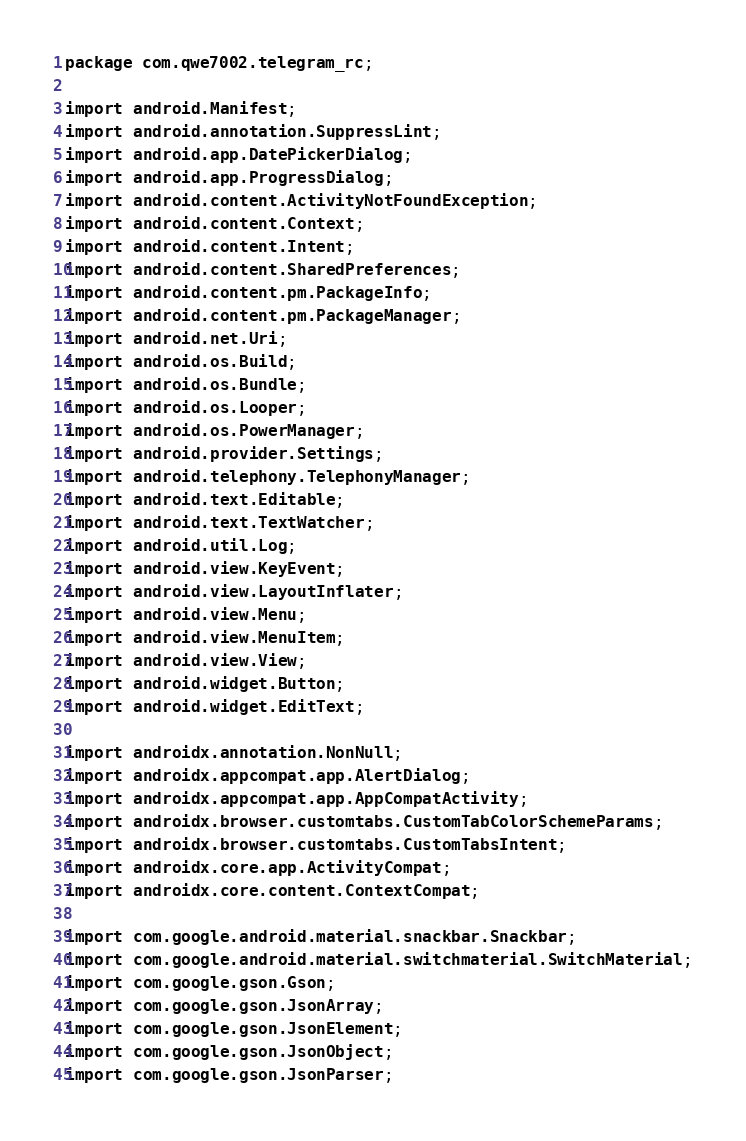Convert code to text. <code><loc_0><loc_0><loc_500><loc_500><_Java_>package com.qwe7002.telegram_rc;

import android.Manifest;
import android.annotation.SuppressLint;
import android.app.DatePickerDialog;
import android.app.ProgressDialog;
import android.content.ActivityNotFoundException;
import android.content.Context;
import android.content.Intent;
import android.content.SharedPreferences;
import android.content.pm.PackageInfo;
import android.content.pm.PackageManager;
import android.net.Uri;
import android.os.Build;
import android.os.Bundle;
import android.os.Looper;
import android.os.PowerManager;
import android.provider.Settings;
import android.telephony.TelephonyManager;
import android.text.Editable;
import android.text.TextWatcher;
import android.util.Log;
import android.view.KeyEvent;
import android.view.LayoutInflater;
import android.view.Menu;
import android.view.MenuItem;
import android.view.View;
import android.widget.Button;
import android.widget.EditText;

import androidx.annotation.NonNull;
import androidx.appcompat.app.AlertDialog;
import androidx.appcompat.app.AppCompatActivity;
import androidx.browser.customtabs.CustomTabColorSchemeParams;
import androidx.browser.customtabs.CustomTabsIntent;
import androidx.core.app.ActivityCompat;
import androidx.core.content.ContextCompat;

import com.google.android.material.snackbar.Snackbar;
import com.google.android.material.switchmaterial.SwitchMaterial;
import com.google.gson.Gson;
import com.google.gson.JsonArray;
import com.google.gson.JsonElement;
import com.google.gson.JsonObject;
import com.google.gson.JsonParser;</code> 